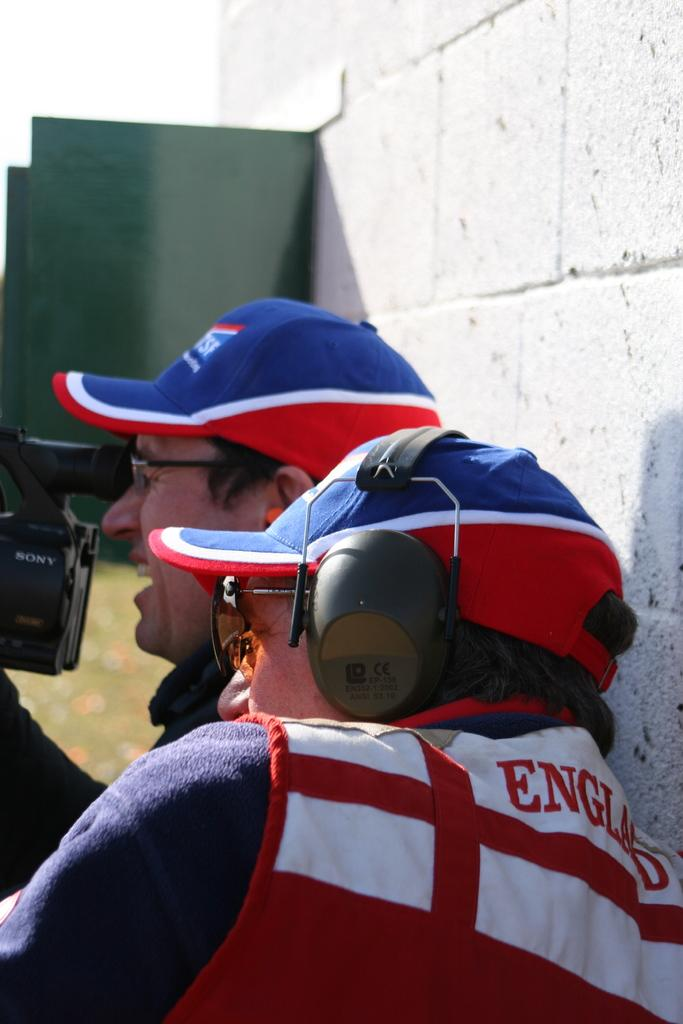How many people are in the image? There are two men standing in the image. What are the men wearing on their heads? Both men are wearing hats. What is one of the men holding? One man is holding a camera. What can be seen in the background of the image? There is a wall visible in the image. Is there any quicksand visible in the image? No, there is no quicksand present in the image. What color is the orange in the image? There is no orange present in the image. 